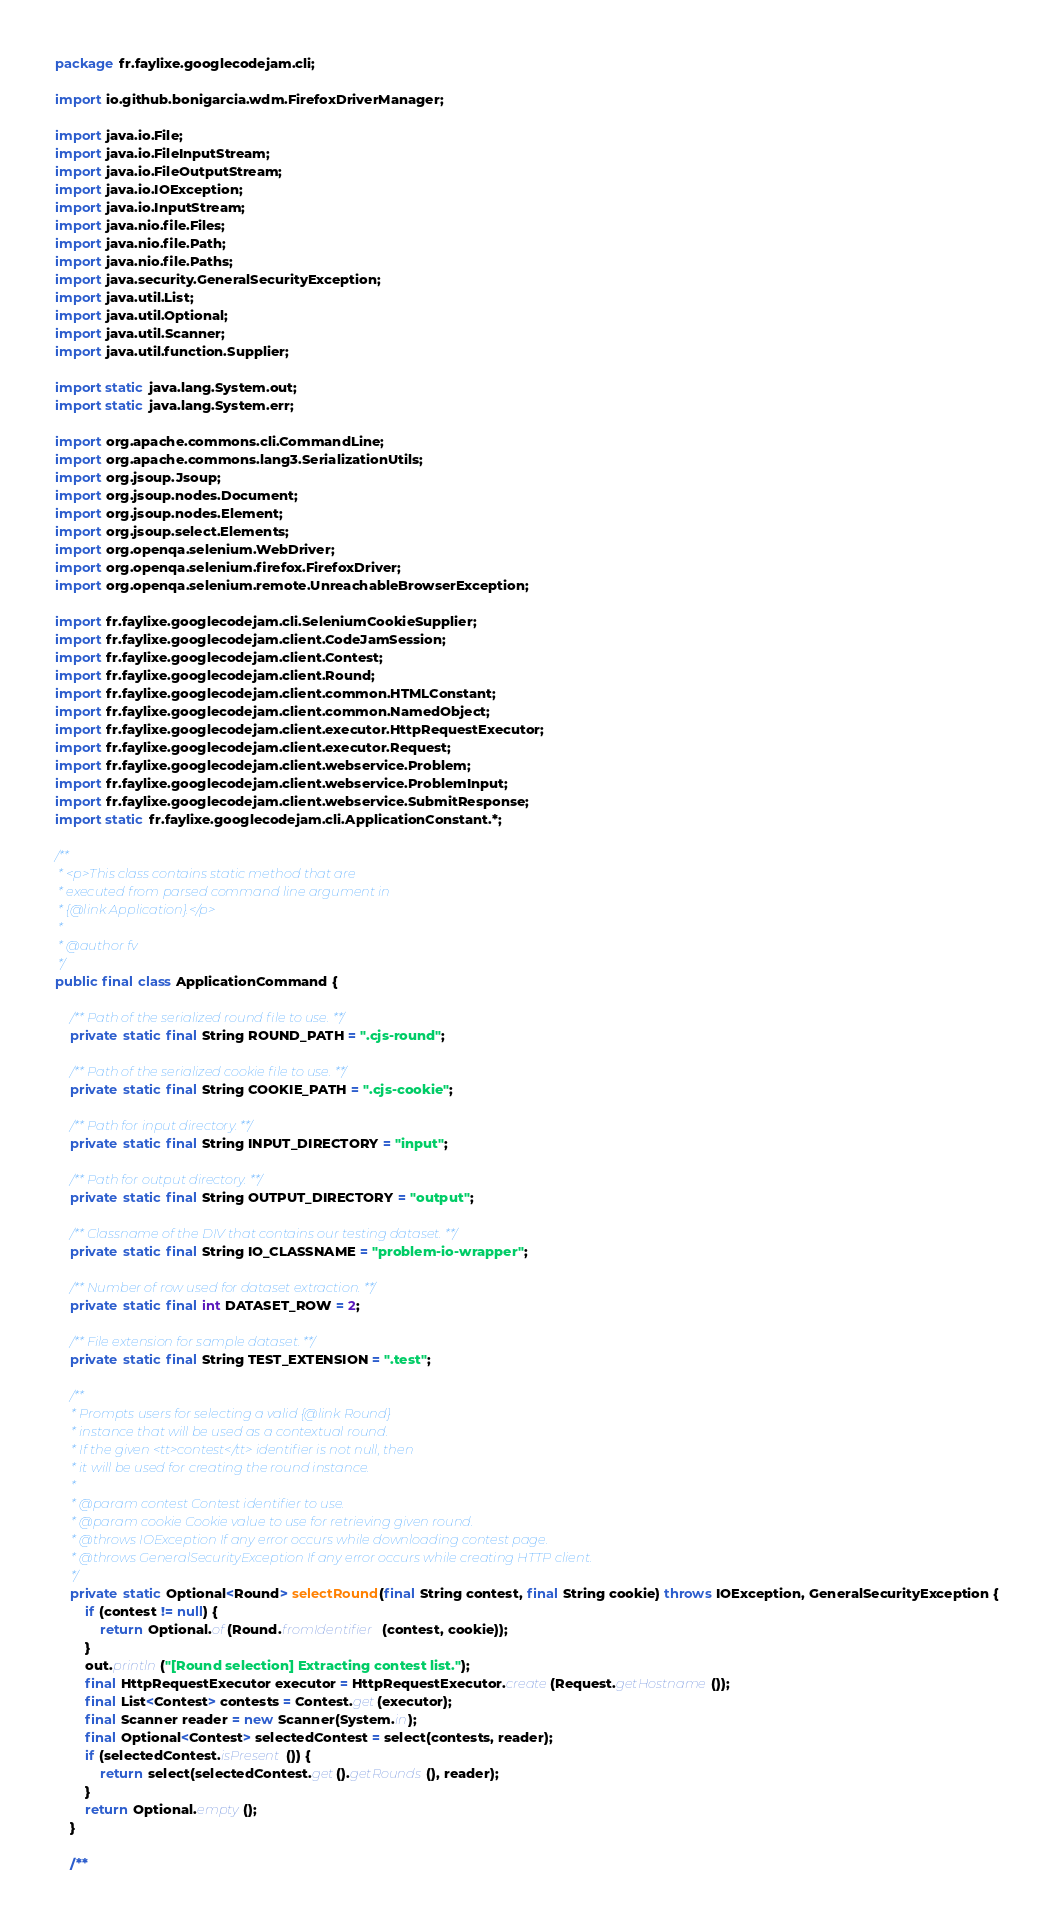Convert code to text. <code><loc_0><loc_0><loc_500><loc_500><_Java_>package fr.faylixe.googlecodejam.cli;

import io.github.bonigarcia.wdm.FirefoxDriverManager;

import java.io.File;
import java.io.FileInputStream;
import java.io.FileOutputStream;
import java.io.IOException;
import java.io.InputStream;
import java.nio.file.Files;
import java.nio.file.Path;
import java.nio.file.Paths;
import java.security.GeneralSecurityException;
import java.util.List;
import java.util.Optional;
import java.util.Scanner;
import java.util.function.Supplier;

import static java.lang.System.out;
import static java.lang.System.err;

import org.apache.commons.cli.CommandLine;
import org.apache.commons.lang3.SerializationUtils;
import org.jsoup.Jsoup;
import org.jsoup.nodes.Document;
import org.jsoup.nodes.Element;
import org.jsoup.select.Elements;
import org.openqa.selenium.WebDriver;
import org.openqa.selenium.firefox.FirefoxDriver;
import org.openqa.selenium.remote.UnreachableBrowserException;

import fr.faylixe.googlecodejam.cli.SeleniumCookieSupplier;
import fr.faylixe.googlecodejam.client.CodeJamSession;
import fr.faylixe.googlecodejam.client.Contest;
import fr.faylixe.googlecodejam.client.Round;
import fr.faylixe.googlecodejam.client.common.HTMLConstant;
import fr.faylixe.googlecodejam.client.common.NamedObject;
import fr.faylixe.googlecodejam.client.executor.HttpRequestExecutor;
import fr.faylixe.googlecodejam.client.executor.Request;
import fr.faylixe.googlecodejam.client.webservice.Problem;
import fr.faylixe.googlecodejam.client.webservice.ProblemInput;
import fr.faylixe.googlecodejam.client.webservice.SubmitResponse;
import static fr.faylixe.googlecodejam.cli.ApplicationConstant.*;

/**
 * <p>This class contains static method that are
 * executed from parsed command line argument in
 * {@link Application}.</p>
 * 
 * @author fv
 */
public final class ApplicationCommand {

	/** Path of the serialized round file to use. **/
	private static final String ROUND_PATH = ".cjs-round";

	/** Path of the serialized cookie file to use. **/
	private static final String COOKIE_PATH = ".cjs-cookie";

	/** Path for input directory. **/
	private static final String INPUT_DIRECTORY = "input";

	/** Path for output directory. **/
	private static final String OUTPUT_DIRECTORY = "output";

	/** Classname of the DIV that contains our testing dataset. **/
	private static final String IO_CLASSNAME = "problem-io-wrapper";

	/** Number of row used for dataset extraction. **/
	private static final int DATASET_ROW = 2;

	/** File extension for sample dataset. **/
	private static final String TEST_EXTENSION = ".test";

	/**
	 * Prompts users for selecting a valid {@link Round}
	 * instance that will be used as a contextual round.
	 * If the given <tt>contest</tt> identifier is not null, then
	 * it will be used for creating the round instance.
	 * 
	 * @param contest Contest identifier to use.
	 * @param cookie Cookie value to use for retrieving given round.
	 * @throws IOException If any error occurs while downloading contest page.
	 * @throws GeneralSecurityException If any error occurs while creating HTTP client.
	 */
	private static Optional<Round> selectRound(final String contest, final String cookie) throws IOException, GeneralSecurityException {
		if (contest != null) {
			return Optional.of(Round.fromIdentifier(contest, cookie));
		}
		out.println("[Round selection] Extracting contest list.");
		final HttpRequestExecutor executor = HttpRequestExecutor.create(Request.getHostname());
		final List<Contest> contests = Contest.get(executor);
		final Scanner reader = new Scanner(System.in);
		final Optional<Contest> selectedContest = select(contests, reader);
		if (selectedContest.isPresent()) {
			return select(selectedContest.get().getRounds(), reader);
		}
		return Optional.empty();
	}

	/**</code> 